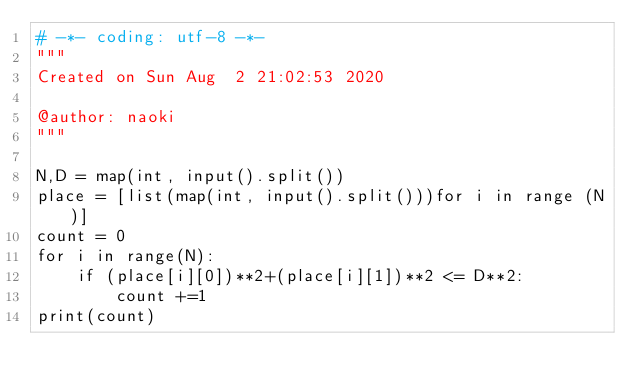<code> <loc_0><loc_0><loc_500><loc_500><_Python_># -*- coding: utf-8 -*-
"""
Created on Sun Aug  2 21:02:53 2020

@author: naoki
"""

N,D = map(int, input().split())
place = [list(map(int, input().split()))for i in range (N)]
count = 0 
for i in range(N):
    if (place[i][0])**2+(place[i][1])**2 <= D**2:
        count +=1
print(count)
        </code> 